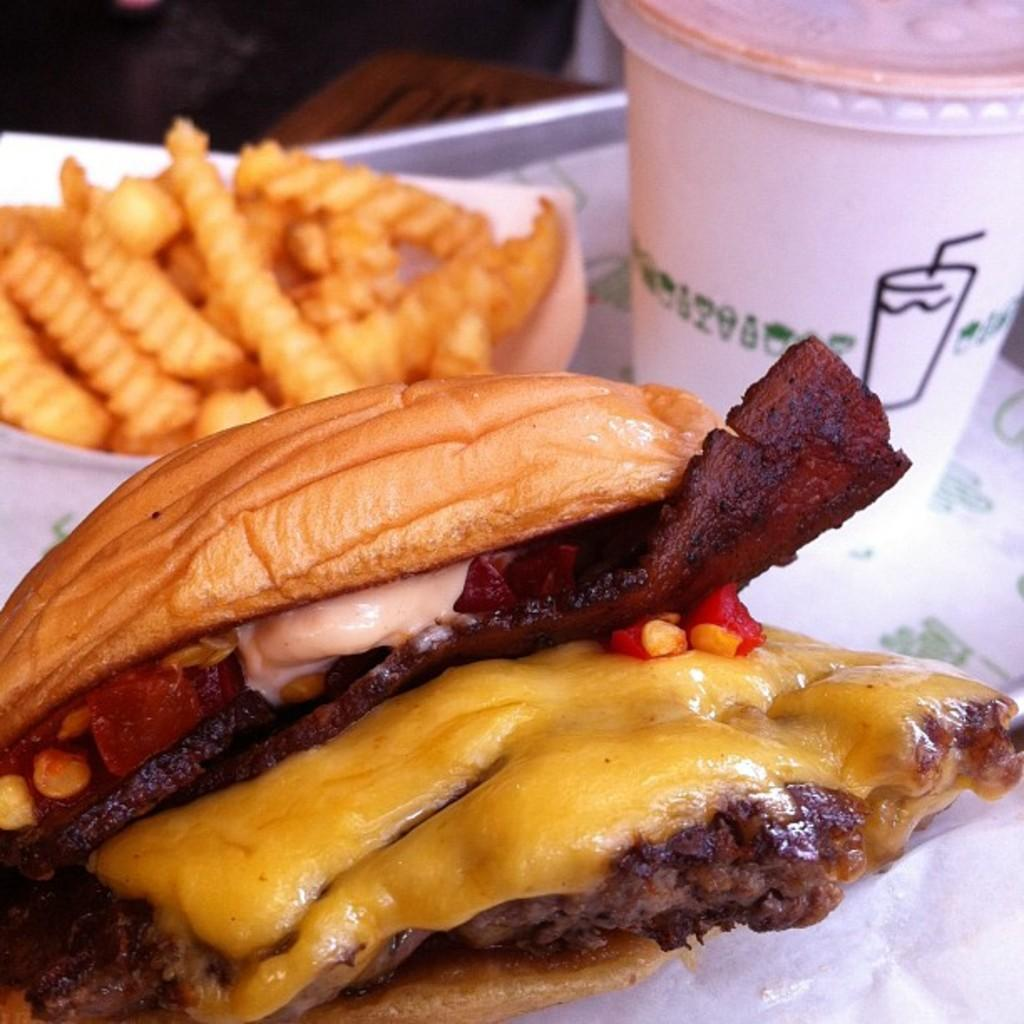What is the main object in the center of the image? There is a table in the center of the image. What items can be found on the table? On the table, there is a plate, tissue paper, a glass, a bowl, and food items. Can you describe the food items on the table? Unfortunately, the facts provided do not specify the type of food items on the table. How many sticks of meat are on the table? There is no mention of sticks of meat or any meat in the image. The facts provided only mention a plate, tissue paper, a glass, a bowl, and food items, without specifying their type. 